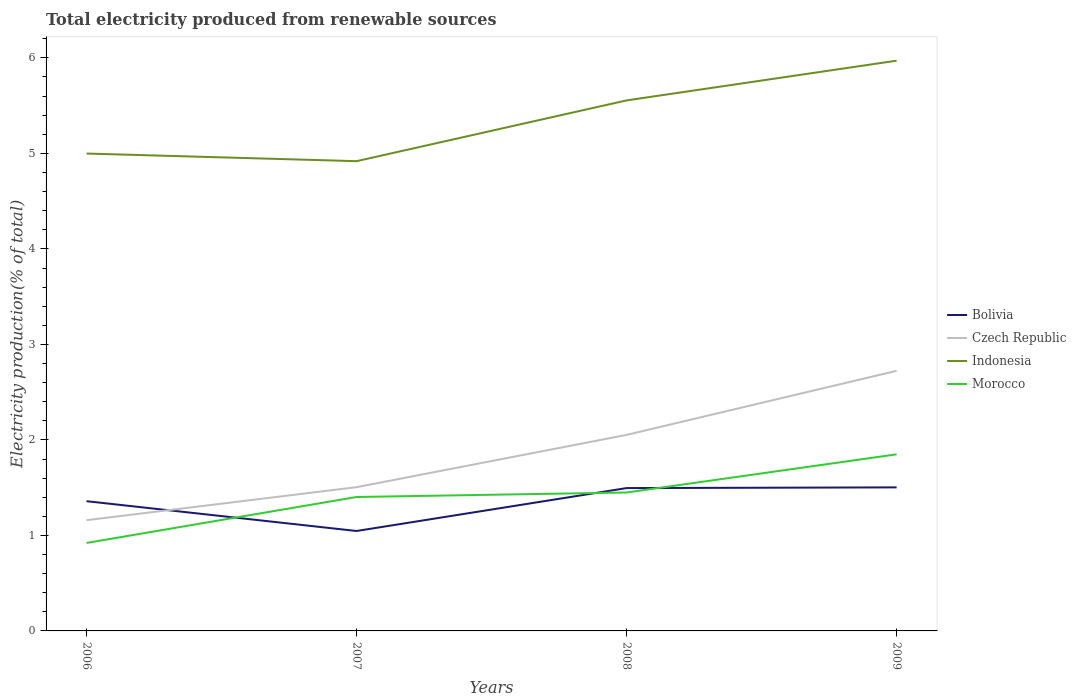Is the number of lines equal to the number of legend labels?
Your answer should be very brief. Yes. Across all years, what is the maximum total electricity produced in Indonesia?
Your answer should be very brief. 4.92. What is the total total electricity produced in Indonesia in the graph?
Your response must be concise. -0.42. What is the difference between the highest and the second highest total electricity produced in Czech Republic?
Ensure brevity in your answer.  1.56. Is the total electricity produced in Czech Republic strictly greater than the total electricity produced in Morocco over the years?
Your answer should be compact. No. How many lines are there?
Provide a short and direct response. 4. Where does the legend appear in the graph?
Provide a succinct answer. Center right. What is the title of the graph?
Offer a terse response. Total electricity produced from renewable sources. What is the label or title of the X-axis?
Make the answer very short. Years. What is the label or title of the Y-axis?
Give a very brief answer. Electricity production(% of total). What is the Electricity production(% of total) of Bolivia in 2006?
Provide a succinct answer. 1.36. What is the Electricity production(% of total) in Czech Republic in 2006?
Your response must be concise. 1.16. What is the Electricity production(% of total) of Indonesia in 2006?
Make the answer very short. 5. What is the Electricity production(% of total) of Morocco in 2006?
Provide a succinct answer. 0.92. What is the Electricity production(% of total) of Bolivia in 2007?
Your response must be concise. 1.05. What is the Electricity production(% of total) in Czech Republic in 2007?
Provide a short and direct response. 1.51. What is the Electricity production(% of total) of Indonesia in 2007?
Your answer should be very brief. 4.92. What is the Electricity production(% of total) in Morocco in 2007?
Give a very brief answer. 1.4. What is the Electricity production(% of total) of Bolivia in 2008?
Provide a short and direct response. 1.5. What is the Electricity production(% of total) of Czech Republic in 2008?
Give a very brief answer. 2.05. What is the Electricity production(% of total) in Indonesia in 2008?
Your answer should be compact. 5.56. What is the Electricity production(% of total) in Morocco in 2008?
Your answer should be very brief. 1.45. What is the Electricity production(% of total) of Bolivia in 2009?
Ensure brevity in your answer.  1.5. What is the Electricity production(% of total) of Czech Republic in 2009?
Your answer should be very brief. 2.72. What is the Electricity production(% of total) of Indonesia in 2009?
Provide a succinct answer. 5.97. What is the Electricity production(% of total) of Morocco in 2009?
Provide a short and direct response. 1.85. Across all years, what is the maximum Electricity production(% of total) in Bolivia?
Keep it short and to the point. 1.5. Across all years, what is the maximum Electricity production(% of total) in Czech Republic?
Your response must be concise. 2.72. Across all years, what is the maximum Electricity production(% of total) in Indonesia?
Keep it short and to the point. 5.97. Across all years, what is the maximum Electricity production(% of total) in Morocco?
Your response must be concise. 1.85. Across all years, what is the minimum Electricity production(% of total) of Bolivia?
Give a very brief answer. 1.05. Across all years, what is the minimum Electricity production(% of total) in Czech Republic?
Your response must be concise. 1.16. Across all years, what is the minimum Electricity production(% of total) of Indonesia?
Provide a short and direct response. 4.92. Across all years, what is the minimum Electricity production(% of total) in Morocco?
Give a very brief answer. 0.92. What is the total Electricity production(% of total) of Bolivia in the graph?
Provide a short and direct response. 5.4. What is the total Electricity production(% of total) in Czech Republic in the graph?
Give a very brief answer. 7.44. What is the total Electricity production(% of total) of Indonesia in the graph?
Provide a succinct answer. 21.44. What is the total Electricity production(% of total) of Morocco in the graph?
Your answer should be compact. 5.62. What is the difference between the Electricity production(% of total) of Bolivia in 2006 and that in 2007?
Your answer should be very brief. 0.31. What is the difference between the Electricity production(% of total) in Czech Republic in 2006 and that in 2007?
Your answer should be very brief. -0.35. What is the difference between the Electricity production(% of total) in Indonesia in 2006 and that in 2007?
Your response must be concise. 0.08. What is the difference between the Electricity production(% of total) of Morocco in 2006 and that in 2007?
Your response must be concise. -0.48. What is the difference between the Electricity production(% of total) of Bolivia in 2006 and that in 2008?
Give a very brief answer. -0.14. What is the difference between the Electricity production(% of total) of Czech Republic in 2006 and that in 2008?
Your response must be concise. -0.89. What is the difference between the Electricity production(% of total) of Indonesia in 2006 and that in 2008?
Your answer should be very brief. -0.56. What is the difference between the Electricity production(% of total) of Morocco in 2006 and that in 2008?
Make the answer very short. -0.53. What is the difference between the Electricity production(% of total) in Bolivia in 2006 and that in 2009?
Offer a very short reply. -0.14. What is the difference between the Electricity production(% of total) in Czech Republic in 2006 and that in 2009?
Provide a short and direct response. -1.56. What is the difference between the Electricity production(% of total) of Indonesia in 2006 and that in 2009?
Your answer should be compact. -0.97. What is the difference between the Electricity production(% of total) of Morocco in 2006 and that in 2009?
Your answer should be compact. -0.93. What is the difference between the Electricity production(% of total) of Bolivia in 2007 and that in 2008?
Provide a short and direct response. -0.45. What is the difference between the Electricity production(% of total) in Czech Republic in 2007 and that in 2008?
Give a very brief answer. -0.55. What is the difference between the Electricity production(% of total) of Indonesia in 2007 and that in 2008?
Make the answer very short. -0.64. What is the difference between the Electricity production(% of total) of Morocco in 2007 and that in 2008?
Your answer should be very brief. -0.05. What is the difference between the Electricity production(% of total) of Bolivia in 2007 and that in 2009?
Provide a short and direct response. -0.46. What is the difference between the Electricity production(% of total) of Czech Republic in 2007 and that in 2009?
Keep it short and to the point. -1.22. What is the difference between the Electricity production(% of total) in Indonesia in 2007 and that in 2009?
Make the answer very short. -1.05. What is the difference between the Electricity production(% of total) of Morocco in 2007 and that in 2009?
Your response must be concise. -0.45. What is the difference between the Electricity production(% of total) of Bolivia in 2008 and that in 2009?
Your answer should be compact. -0.01. What is the difference between the Electricity production(% of total) in Czech Republic in 2008 and that in 2009?
Offer a terse response. -0.67. What is the difference between the Electricity production(% of total) of Indonesia in 2008 and that in 2009?
Ensure brevity in your answer.  -0.42. What is the difference between the Electricity production(% of total) in Morocco in 2008 and that in 2009?
Offer a very short reply. -0.4. What is the difference between the Electricity production(% of total) in Bolivia in 2006 and the Electricity production(% of total) in Czech Republic in 2007?
Give a very brief answer. -0.15. What is the difference between the Electricity production(% of total) in Bolivia in 2006 and the Electricity production(% of total) in Indonesia in 2007?
Your answer should be compact. -3.56. What is the difference between the Electricity production(% of total) of Bolivia in 2006 and the Electricity production(% of total) of Morocco in 2007?
Provide a succinct answer. -0.04. What is the difference between the Electricity production(% of total) of Czech Republic in 2006 and the Electricity production(% of total) of Indonesia in 2007?
Give a very brief answer. -3.76. What is the difference between the Electricity production(% of total) of Czech Republic in 2006 and the Electricity production(% of total) of Morocco in 2007?
Your answer should be very brief. -0.24. What is the difference between the Electricity production(% of total) in Indonesia in 2006 and the Electricity production(% of total) in Morocco in 2007?
Ensure brevity in your answer.  3.6. What is the difference between the Electricity production(% of total) in Bolivia in 2006 and the Electricity production(% of total) in Czech Republic in 2008?
Give a very brief answer. -0.69. What is the difference between the Electricity production(% of total) of Bolivia in 2006 and the Electricity production(% of total) of Indonesia in 2008?
Keep it short and to the point. -4.2. What is the difference between the Electricity production(% of total) in Bolivia in 2006 and the Electricity production(% of total) in Morocco in 2008?
Your answer should be compact. -0.09. What is the difference between the Electricity production(% of total) of Czech Republic in 2006 and the Electricity production(% of total) of Indonesia in 2008?
Offer a terse response. -4.4. What is the difference between the Electricity production(% of total) in Czech Republic in 2006 and the Electricity production(% of total) in Morocco in 2008?
Provide a succinct answer. -0.29. What is the difference between the Electricity production(% of total) of Indonesia in 2006 and the Electricity production(% of total) of Morocco in 2008?
Ensure brevity in your answer.  3.55. What is the difference between the Electricity production(% of total) in Bolivia in 2006 and the Electricity production(% of total) in Czech Republic in 2009?
Give a very brief answer. -1.36. What is the difference between the Electricity production(% of total) in Bolivia in 2006 and the Electricity production(% of total) in Indonesia in 2009?
Give a very brief answer. -4.61. What is the difference between the Electricity production(% of total) in Bolivia in 2006 and the Electricity production(% of total) in Morocco in 2009?
Give a very brief answer. -0.49. What is the difference between the Electricity production(% of total) in Czech Republic in 2006 and the Electricity production(% of total) in Indonesia in 2009?
Keep it short and to the point. -4.81. What is the difference between the Electricity production(% of total) in Czech Republic in 2006 and the Electricity production(% of total) in Morocco in 2009?
Offer a very short reply. -0.69. What is the difference between the Electricity production(% of total) in Indonesia in 2006 and the Electricity production(% of total) in Morocco in 2009?
Your answer should be compact. 3.15. What is the difference between the Electricity production(% of total) in Bolivia in 2007 and the Electricity production(% of total) in Czech Republic in 2008?
Offer a terse response. -1.01. What is the difference between the Electricity production(% of total) of Bolivia in 2007 and the Electricity production(% of total) of Indonesia in 2008?
Provide a short and direct response. -4.51. What is the difference between the Electricity production(% of total) in Bolivia in 2007 and the Electricity production(% of total) in Morocco in 2008?
Your answer should be compact. -0.4. What is the difference between the Electricity production(% of total) of Czech Republic in 2007 and the Electricity production(% of total) of Indonesia in 2008?
Provide a short and direct response. -4.05. What is the difference between the Electricity production(% of total) in Czech Republic in 2007 and the Electricity production(% of total) in Morocco in 2008?
Make the answer very short. 0.06. What is the difference between the Electricity production(% of total) of Indonesia in 2007 and the Electricity production(% of total) of Morocco in 2008?
Your answer should be very brief. 3.47. What is the difference between the Electricity production(% of total) in Bolivia in 2007 and the Electricity production(% of total) in Czech Republic in 2009?
Make the answer very short. -1.68. What is the difference between the Electricity production(% of total) in Bolivia in 2007 and the Electricity production(% of total) in Indonesia in 2009?
Ensure brevity in your answer.  -4.92. What is the difference between the Electricity production(% of total) of Bolivia in 2007 and the Electricity production(% of total) of Morocco in 2009?
Offer a very short reply. -0.8. What is the difference between the Electricity production(% of total) in Czech Republic in 2007 and the Electricity production(% of total) in Indonesia in 2009?
Provide a short and direct response. -4.47. What is the difference between the Electricity production(% of total) in Czech Republic in 2007 and the Electricity production(% of total) in Morocco in 2009?
Give a very brief answer. -0.34. What is the difference between the Electricity production(% of total) of Indonesia in 2007 and the Electricity production(% of total) of Morocco in 2009?
Your answer should be compact. 3.07. What is the difference between the Electricity production(% of total) of Bolivia in 2008 and the Electricity production(% of total) of Czech Republic in 2009?
Provide a short and direct response. -1.23. What is the difference between the Electricity production(% of total) in Bolivia in 2008 and the Electricity production(% of total) in Indonesia in 2009?
Give a very brief answer. -4.48. What is the difference between the Electricity production(% of total) in Bolivia in 2008 and the Electricity production(% of total) in Morocco in 2009?
Your answer should be compact. -0.35. What is the difference between the Electricity production(% of total) of Czech Republic in 2008 and the Electricity production(% of total) of Indonesia in 2009?
Your response must be concise. -3.92. What is the difference between the Electricity production(% of total) in Czech Republic in 2008 and the Electricity production(% of total) in Morocco in 2009?
Offer a very short reply. 0.2. What is the difference between the Electricity production(% of total) of Indonesia in 2008 and the Electricity production(% of total) of Morocco in 2009?
Offer a very short reply. 3.71. What is the average Electricity production(% of total) in Bolivia per year?
Provide a succinct answer. 1.35. What is the average Electricity production(% of total) in Czech Republic per year?
Offer a very short reply. 1.86. What is the average Electricity production(% of total) in Indonesia per year?
Your answer should be compact. 5.36. What is the average Electricity production(% of total) in Morocco per year?
Give a very brief answer. 1.41. In the year 2006, what is the difference between the Electricity production(% of total) of Bolivia and Electricity production(% of total) of Czech Republic?
Keep it short and to the point. 0.2. In the year 2006, what is the difference between the Electricity production(% of total) of Bolivia and Electricity production(% of total) of Indonesia?
Provide a short and direct response. -3.64. In the year 2006, what is the difference between the Electricity production(% of total) of Bolivia and Electricity production(% of total) of Morocco?
Your answer should be very brief. 0.44. In the year 2006, what is the difference between the Electricity production(% of total) of Czech Republic and Electricity production(% of total) of Indonesia?
Make the answer very short. -3.84. In the year 2006, what is the difference between the Electricity production(% of total) of Czech Republic and Electricity production(% of total) of Morocco?
Offer a terse response. 0.24. In the year 2006, what is the difference between the Electricity production(% of total) of Indonesia and Electricity production(% of total) of Morocco?
Offer a very short reply. 4.08. In the year 2007, what is the difference between the Electricity production(% of total) in Bolivia and Electricity production(% of total) in Czech Republic?
Keep it short and to the point. -0.46. In the year 2007, what is the difference between the Electricity production(% of total) in Bolivia and Electricity production(% of total) in Indonesia?
Keep it short and to the point. -3.87. In the year 2007, what is the difference between the Electricity production(% of total) in Bolivia and Electricity production(% of total) in Morocco?
Your response must be concise. -0.36. In the year 2007, what is the difference between the Electricity production(% of total) of Czech Republic and Electricity production(% of total) of Indonesia?
Make the answer very short. -3.41. In the year 2007, what is the difference between the Electricity production(% of total) of Czech Republic and Electricity production(% of total) of Morocco?
Your answer should be very brief. 0.1. In the year 2007, what is the difference between the Electricity production(% of total) of Indonesia and Electricity production(% of total) of Morocco?
Make the answer very short. 3.52. In the year 2008, what is the difference between the Electricity production(% of total) in Bolivia and Electricity production(% of total) in Czech Republic?
Your answer should be very brief. -0.56. In the year 2008, what is the difference between the Electricity production(% of total) in Bolivia and Electricity production(% of total) in Indonesia?
Your response must be concise. -4.06. In the year 2008, what is the difference between the Electricity production(% of total) in Bolivia and Electricity production(% of total) in Morocco?
Provide a succinct answer. 0.05. In the year 2008, what is the difference between the Electricity production(% of total) of Czech Republic and Electricity production(% of total) of Indonesia?
Provide a succinct answer. -3.5. In the year 2008, what is the difference between the Electricity production(% of total) in Czech Republic and Electricity production(% of total) in Morocco?
Make the answer very short. 0.6. In the year 2008, what is the difference between the Electricity production(% of total) in Indonesia and Electricity production(% of total) in Morocco?
Ensure brevity in your answer.  4.11. In the year 2009, what is the difference between the Electricity production(% of total) of Bolivia and Electricity production(% of total) of Czech Republic?
Provide a succinct answer. -1.22. In the year 2009, what is the difference between the Electricity production(% of total) in Bolivia and Electricity production(% of total) in Indonesia?
Offer a very short reply. -4.47. In the year 2009, what is the difference between the Electricity production(% of total) of Bolivia and Electricity production(% of total) of Morocco?
Offer a very short reply. -0.35. In the year 2009, what is the difference between the Electricity production(% of total) of Czech Republic and Electricity production(% of total) of Indonesia?
Offer a very short reply. -3.25. In the year 2009, what is the difference between the Electricity production(% of total) of Czech Republic and Electricity production(% of total) of Morocco?
Your response must be concise. 0.87. In the year 2009, what is the difference between the Electricity production(% of total) of Indonesia and Electricity production(% of total) of Morocco?
Ensure brevity in your answer.  4.12. What is the ratio of the Electricity production(% of total) of Bolivia in 2006 to that in 2007?
Give a very brief answer. 1.3. What is the ratio of the Electricity production(% of total) in Czech Republic in 2006 to that in 2007?
Your answer should be very brief. 0.77. What is the ratio of the Electricity production(% of total) in Indonesia in 2006 to that in 2007?
Keep it short and to the point. 1.02. What is the ratio of the Electricity production(% of total) of Morocco in 2006 to that in 2007?
Your answer should be very brief. 0.66. What is the ratio of the Electricity production(% of total) in Bolivia in 2006 to that in 2008?
Provide a short and direct response. 0.91. What is the ratio of the Electricity production(% of total) of Czech Republic in 2006 to that in 2008?
Make the answer very short. 0.56. What is the ratio of the Electricity production(% of total) in Indonesia in 2006 to that in 2008?
Provide a succinct answer. 0.9. What is the ratio of the Electricity production(% of total) in Morocco in 2006 to that in 2008?
Ensure brevity in your answer.  0.64. What is the ratio of the Electricity production(% of total) in Bolivia in 2006 to that in 2009?
Provide a succinct answer. 0.9. What is the ratio of the Electricity production(% of total) of Czech Republic in 2006 to that in 2009?
Offer a terse response. 0.43. What is the ratio of the Electricity production(% of total) of Indonesia in 2006 to that in 2009?
Your response must be concise. 0.84. What is the ratio of the Electricity production(% of total) in Morocco in 2006 to that in 2009?
Your answer should be very brief. 0.5. What is the ratio of the Electricity production(% of total) of Bolivia in 2007 to that in 2008?
Give a very brief answer. 0.7. What is the ratio of the Electricity production(% of total) in Czech Republic in 2007 to that in 2008?
Your response must be concise. 0.73. What is the ratio of the Electricity production(% of total) in Indonesia in 2007 to that in 2008?
Keep it short and to the point. 0.89. What is the ratio of the Electricity production(% of total) of Morocco in 2007 to that in 2008?
Your answer should be compact. 0.97. What is the ratio of the Electricity production(% of total) in Bolivia in 2007 to that in 2009?
Offer a terse response. 0.7. What is the ratio of the Electricity production(% of total) of Czech Republic in 2007 to that in 2009?
Make the answer very short. 0.55. What is the ratio of the Electricity production(% of total) in Indonesia in 2007 to that in 2009?
Make the answer very short. 0.82. What is the ratio of the Electricity production(% of total) in Morocco in 2007 to that in 2009?
Your answer should be compact. 0.76. What is the ratio of the Electricity production(% of total) in Czech Republic in 2008 to that in 2009?
Your response must be concise. 0.75. What is the ratio of the Electricity production(% of total) of Indonesia in 2008 to that in 2009?
Your response must be concise. 0.93. What is the ratio of the Electricity production(% of total) in Morocco in 2008 to that in 2009?
Offer a very short reply. 0.78. What is the difference between the highest and the second highest Electricity production(% of total) in Bolivia?
Your answer should be compact. 0.01. What is the difference between the highest and the second highest Electricity production(% of total) of Czech Republic?
Your answer should be compact. 0.67. What is the difference between the highest and the second highest Electricity production(% of total) in Indonesia?
Keep it short and to the point. 0.42. What is the difference between the highest and the second highest Electricity production(% of total) of Morocco?
Provide a short and direct response. 0.4. What is the difference between the highest and the lowest Electricity production(% of total) in Bolivia?
Make the answer very short. 0.46. What is the difference between the highest and the lowest Electricity production(% of total) of Czech Republic?
Keep it short and to the point. 1.56. What is the difference between the highest and the lowest Electricity production(% of total) in Indonesia?
Make the answer very short. 1.05. What is the difference between the highest and the lowest Electricity production(% of total) in Morocco?
Your response must be concise. 0.93. 